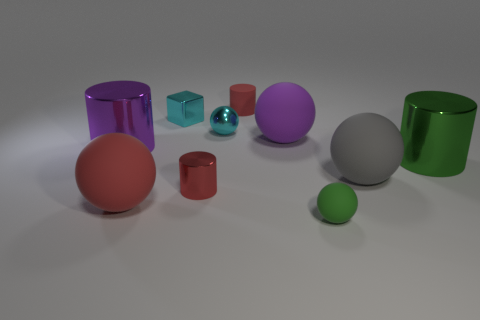What materials are the objects in the image made of, and how can you tell? The objects in the image seem to be made of different kinds of materials based on their appearance. For instance, the green cylinder looks shiny, suggesting it could be made of a polished metal or plastic. The transparency of the purple cube indicates it could be glass or acrylic, and the matte finish of the gray ball suggests a non-reflective material like stone or rubber. 